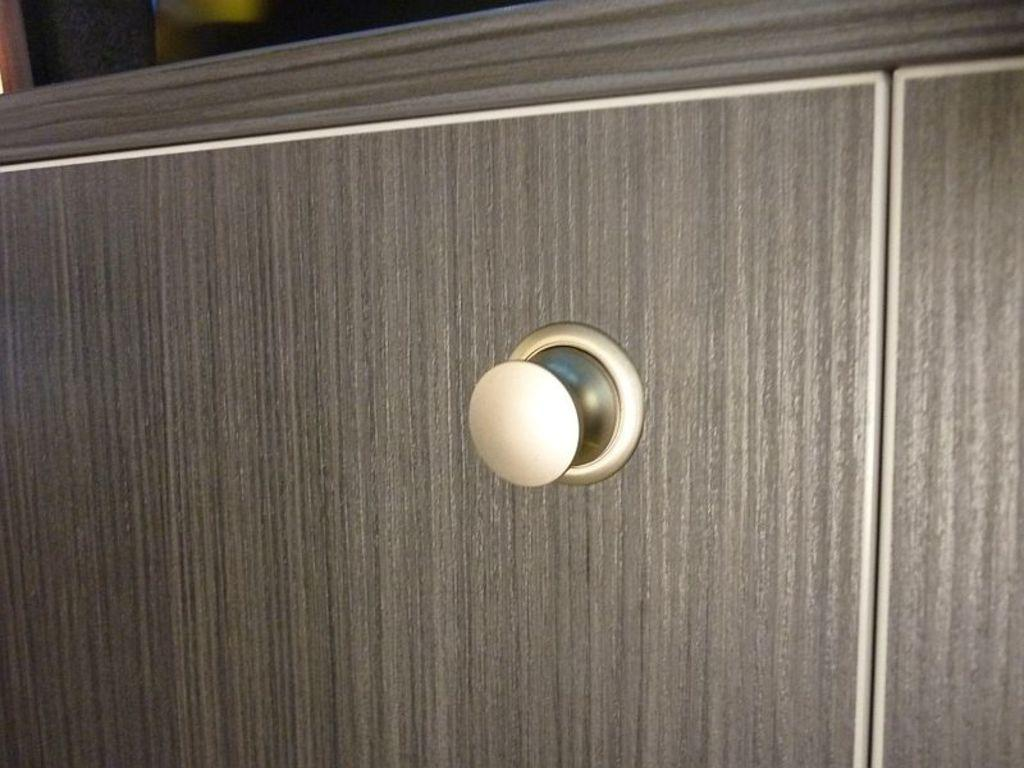What type of furniture is present in the image? There is a cupboard in the image. What colors are used for the cupboard? The cupboard is in cream and grey color. Can you describe the background of the image? The background of the image is blurred. How does the cupboard express anger in the image? The cupboard does not express anger in the image, as it is an inanimate object and cannot display emotions. 